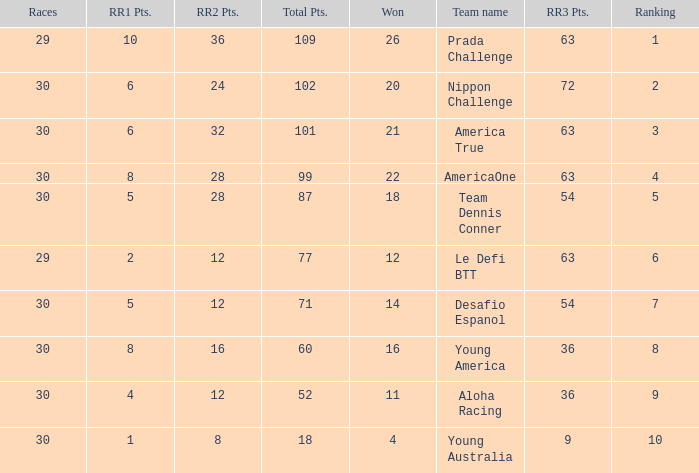Identify the competitions for the prada challenge. 29.0. 